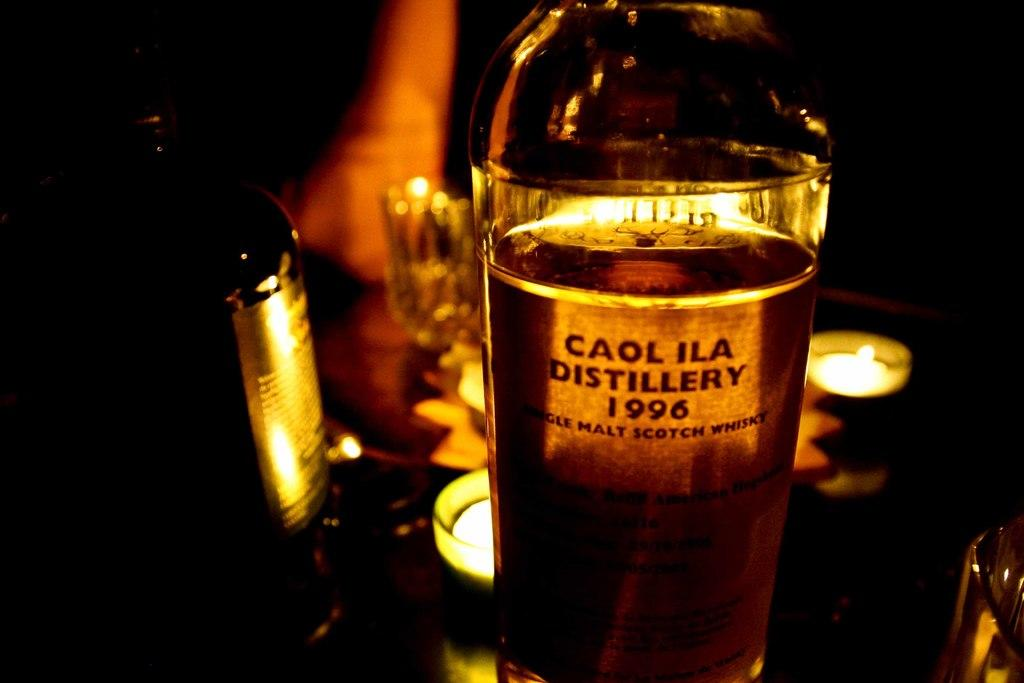<image>
Provide a brief description of the given image. Bottle of beer called Caol Ila placed on top of a table. 